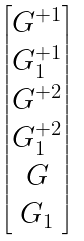Convert formula to latex. <formula><loc_0><loc_0><loc_500><loc_500>\begin{bmatrix} G ^ { + 1 } \\ G ^ { + 1 } _ { 1 } \\ G ^ { + 2 } \\ G ^ { + 2 } _ { 1 } \\ G \\ G _ { 1 } \end{bmatrix}</formula> 